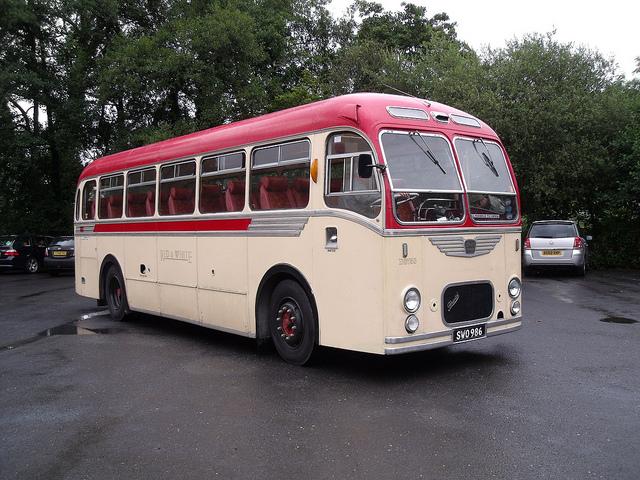How many buses are here?
Keep it brief. 1. Is there a passenger on the bus?
Give a very brief answer. No. Is that an American bus?
Be succinct. No. Are there people standing behind the bus?
Concise answer only. No. What colors are inside the bus?
Concise answer only. Red. 